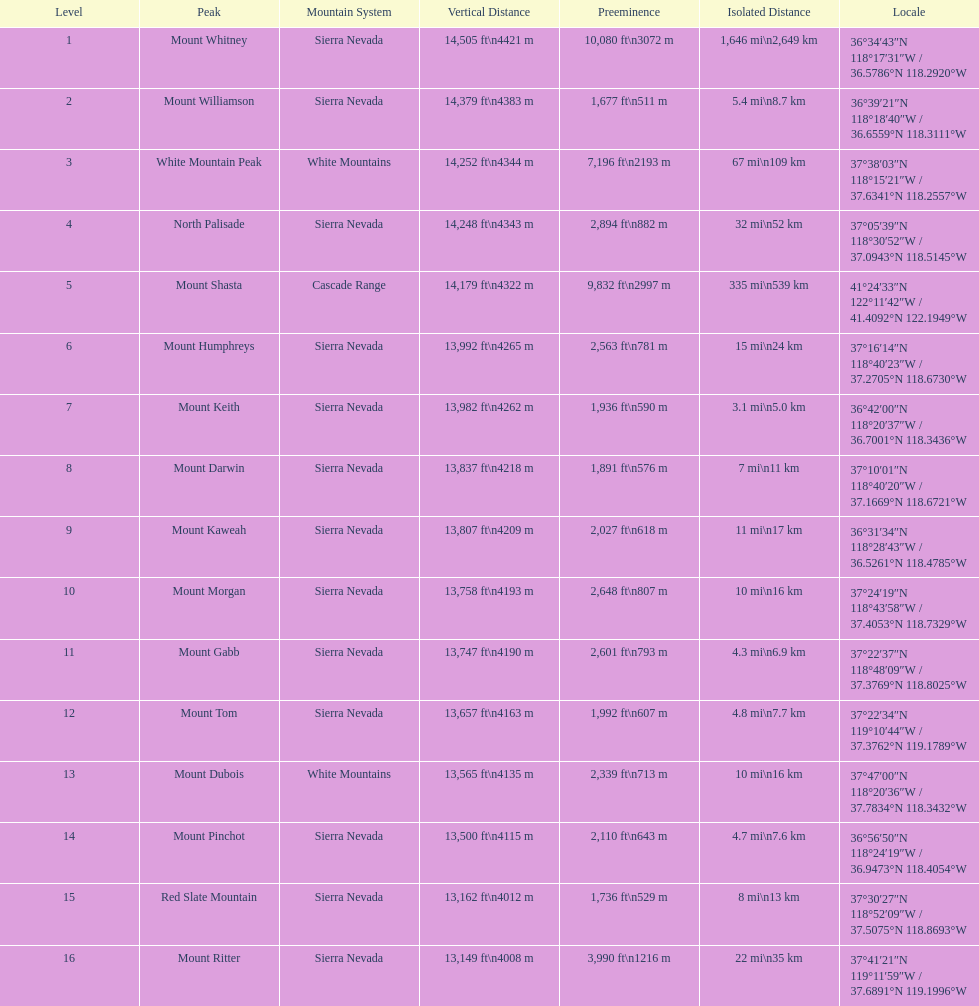What is the next highest mountain peak after north palisade? Mount Shasta. 